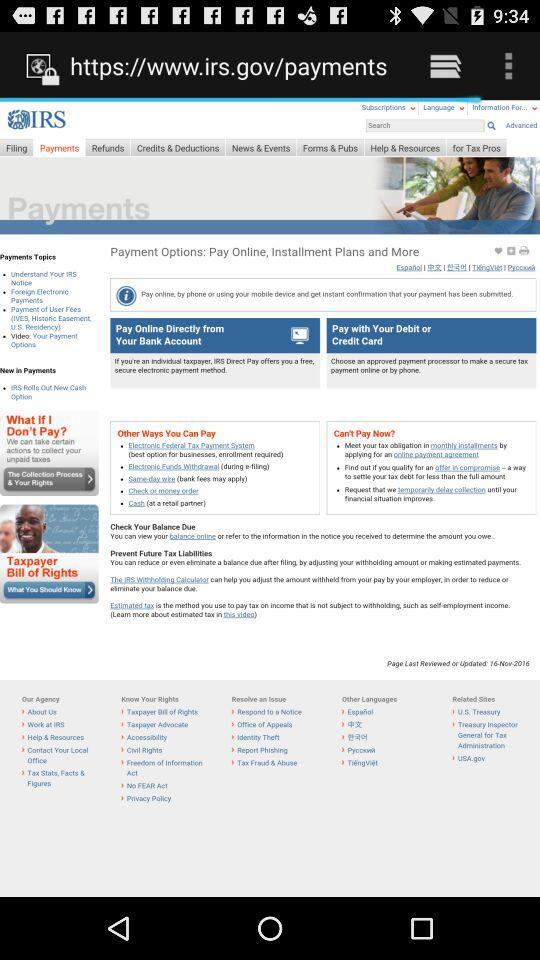What is the name of the application? The name of the application is "IRS". 